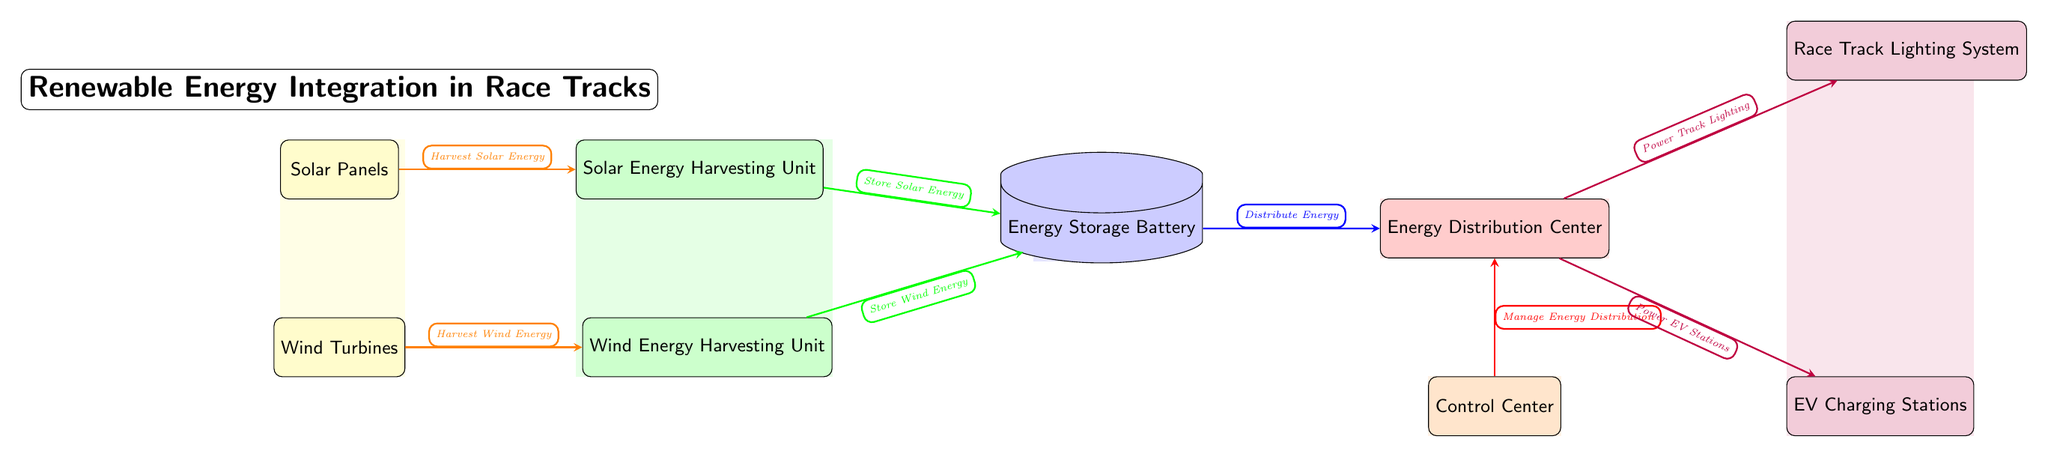What are the two sources of renewable energy shown in the diagram? The diagram identifies two renewable energy sources: Solar Panels and Wind Turbines. These are clearly labeled at the top of the diagram.
Answer: Solar Panels, Wind Turbines How many harvesting units are depicted in the diagram? According to the diagram, there are two harvesting units: one for solar energy and one for wind energy. They are positioned next to their respective sources.
Answer: 2 What direction does energy flow from the Solar Energy Harvesting Unit to the Energy Storage Battery? The diagram indicates that energy flows from the Solar Energy Harvesting Unit to the Energy Storage Battery in a rightward direction, as evidenced by the arrow connecting the two components.
Answer: Right Which system is powered by energy from the Energy Distribution Center? The Energy Distribution Center powers the Race Track Lighting System and the EV Charging Stations, both of which are connected by arrows indicating energy flow from the distribution center.
Answer: Race Track Lighting System, EV Charging Stations What is the function of the Control Center in relation to the Energy Distribution Center? The Control Center manages the energy distribution to ensure that the Energy Distribution Center operates efficiently, as indicated by the directional arrow and label connecting the two elements.
Answer: Manage Energy Distribution What color represents the Energy Storage Battery in the diagram? The Energy Storage Battery is represented in blue, making it distinct from other components on the diagram. The color coding helps in easily identifying different functions.
Answer: Blue How many edges are present in the diagram? The diagram contains seven arrows or edges, each indicating the flow of energy or management between the nodes, which can be counted directly from the connections.
Answer: 7 What role does the Wind Energy Harvesting Unit play in the energy system? The Wind Energy Harvesting Unit's role is to harvest wind energy, which is conveyed through the labeled arrow leading to the Energy Storage Battery. This unit contributes to the overall energy storage for the system.
Answer: Harvest Wind Energy 